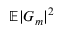Convert formula to latex. <formula><loc_0><loc_0><loc_500><loc_500>\mathbb { E } | G _ { m } | ^ { 2 }</formula> 